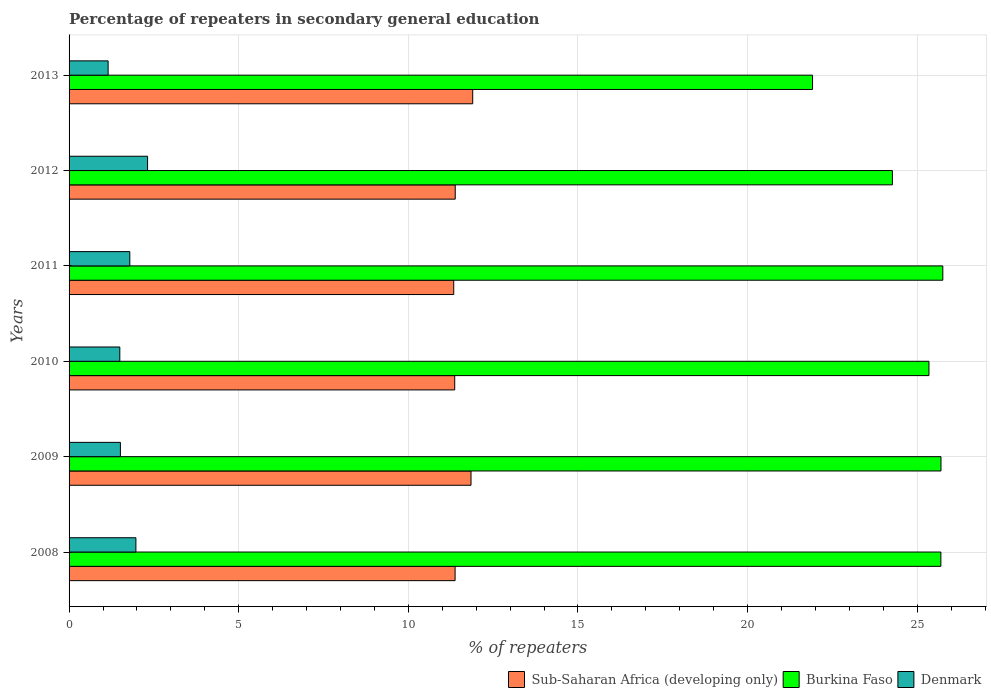How many different coloured bars are there?
Keep it short and to the point. 3. How many groups of bars are there?
Keep it short and to the point. 6. How many bars are there on the 6th tick from the top?
Offer a terse response. 3. How many bars are there on the 4th tick from the bottom?
Your response must be concise. 3. What is the percentage of repeaters in secondary general education in Sub-Saharan Africa (developing only) in 2012?
Offer a very short reply. 11.38. Across all years, what is the maximum percentage of repeaters in secondary general education in Sub-Saharan Africa (developing only)?
Your answer should be very brief. 11.9. Across all years, what is the minimum percentage of repeaters in secondary general education in Burkina Faso?
Keep it short and to the point. 21.91. In which year was the percentage of repeaters in secondary general education in Sub-Saharan Africa (developing only) maximum?
Make the answer very short. 2013. In which year was the percentage of repeaters in secondary general education in Denmark minimum?
Provide a succinct answer. 2013. What is the total percentage of repeaters in secondary general education in Sub-Saharan Africa (developing only) in the graph?
Provide a short and direct response. 69.21. What is the difference between the percentage of repeaters in secondary general education in Denmark in 2009 and that in 2010?
Provide a short and direct response. 0.02. What is the difference between the percentage of repeaters in secondary general education in Denmark in 2010 and the percentage of repeaters in secondary general education in Burkina Faso in 2013?
Your response must be concise. -20.42. What is the average percentage of repeaters in secondary general education in Sub-Saharan Africa (developing only) per year?
Make the answer very short. 11.54. In the year 2009, what is the difference between the percentage of repeaters in secondary general education in Burkina Faso and percentage of repeaters in secondary general education in Denmark?
Keep it short and to the point. 24.19. What is the ratio of the percentage of repeaters in secondary general education in Sub-Saharan Africa (developing only) in 2010 to that in 2013?
Offer a terse response. 0.96. Is the percentage of repeaters in secondary general education in Burkina Faso in 2012 less than that in 2013?
Make the answer very short. No. Is the difference between the percentage of repeaters in secondary general education in Burkina Faso in 2010 and 2013 greater than the difference between the percentage of repeaters in secondary general education in Denmark in 2010 and 2013?
Provide a succinct answer. Yes. What is the difference between the highest and the second highest percentage of repeaters in secondary general education in Burkina Faso?
Ensure brevity in your answer.  0.05. What is the difference between the highest and the lowest percentage of repeaters in secondary general education in Burkina Faso?
Make the answer very short. 3.84. Is the sum of the percentage of repeaters in secondary general education in Sub-Saharan Africa (developing only) in 2011 and 2012 greater than the maximum percentage of repeaters in secondary general education in Denmark across all years?
Your answer should be very brief. Yes. What does the 2nd bar from the top in 2012 represents?
Give a very brief answer. Burkina Faso. What does the 2nd bar from the bottom in 2009 represents?
Ensure brevity in your answer.  Burkina Faso. Is it the case that in every year, the sum of the percentage of repeaters in secondary general education in Denmark and percentage of repeaters in secondary general education in Burkina Faso is greater than the percentage of repeaters in secondary general education in Sub-Saharan Africa (developing only)?
Your answer should be compact. Yes. How many bars are there?
Your response must be concise. 18. Are all the bars in the graph horizontal?
Provide a succinct answer. Yes. Are the values on the major ticks of X-axis written in scientific E-notation?
Your answer should be compact. No. How many legend labels are there?
Make the answer very short. 3. What is the title of the graph?
Give a very brief answer. Percentage of repeaters in secondary general education. What is the label or title of the X-axis?
Make the answer very short. % of repeaters. What is the label or title of the Y-axis?
Ensure brevity in your answer.  Years. What is the % of repeaters in Sub-Saharan Africa (developing only) in 2008?
Offer a very short reply. 11.38. What is the % of repeaters of Burkina Faso in 2008?
Your response must be concise. 25.7. What is the % of repeaters of Denmark in 2008?
Provide a succinct answer. 1.97. What is the % of repeaters of Sub-Saharan Africa (developing only) in 2009?
Your response must be concise. 11.85. What is the % of repeaters of Burkina Faso in 2009?
Make the answer very short. 25.7. What is the % of repeaters in Denmark in 2009?
Give a very brief answer. 1.51. What is the % of repeaters in Sub-Saharan Africa (developing only) in 2010?
Offer a very short reply. 11.37. What is the % of repeaters in Burkina Faso in 2010?
Make the answer very short. 25.35. What is the % of repeaters in Denmark in 2010?
Your answer should be very brief. 1.5. What is the % of repeaters of Sub-Saharan Africa (developing only) in 2011?
Make the answer very short. 11.34. What is the % of repeaters of Burkina Faso in 2011?
Your answer should be compact. 25.75. What is the % of repeaters in Denmark in 2011?
Offer a very short reply. 1.79. What is the % of repeaters in Sub-Saharan Africa (developing only) in 2012?
Provide a succinct answer. 11.38. What is the % of repeaters in Burkina Faso in 2012?
Your answer should be compact. 24.27. What is the % of repeaters in Denmark in 2012?
Your answer should be very brief. 2.31. What is the % of repeaters of Sub-Saharan Africa (developing only) in 2013?
Offer a terse response. 11.9. What is the % of repeaters in Burkina Faso in 2013?
Make the answer very short. 21.91. What is the % of repeaters in Denmark in 2013?
Offer a very short reply. 1.15. Across all years, what is the maximum % of repeaters in Sub-Saharan Africa (developing only)?
Your answer should be compact. 11.9. Across all years, what is the maximum % of repeaters in Burkina Faso?
Offer a terse response. 25.75. Across all years, what is the maximum % of repeaters of Denmark?
Offer a terse response. 2.31. Across all years, what is the minimum % of repeaters in Sub-Saharan Africa (developing only)?
Make the answer very short. 11.34. Across all years, what is the minimum % of repeaters of Burkina Faso?
Your response must be concise. 21.91. Across all years, what is the minimum % of repeaters of Denmark?
Ensure brevity in your answer.  1.15. What is the total % of repeaters in Sub-Saharan Africa (developing only) in the graph?
Give a very brief answer. 69.21. What is the total % of repeaters in Burkina Faso in the graph?
Your response must be concise. 148.68. What is the total % of repeaters in Denmark in the graph?
Provide a short and direct response. 10.23. What is the difference between the % of repeaters in Sub-Saharan Africa (developing only) in 2008 and that in 2009?
Keep it short and to the point. -0.47. What is the difference between the % of repeaters of Burkina Faso in 2008 and that in 2009?
Ensure brevity in your answer.  -0. What is the difference between the % of repeaters of Denmark in 2008 and that in 2009?
Your response must be concise. 0.46. What is the difference between the % of repeaters in Sub-Saharan Africa (developing only) in 2008 and that in 2010?
Offer a terse response. 0.01. What is the difference between the % of repeaters of Burkina Faso in 2008 and that in 2010?
Your answer should be very brief. 0.35. What is the difference between the % of repeaters in Denmark in 2008 and that in 2010?
Offer a terse response. 0.47. What is the difference between the % of repeaters of Sub-Saharan Africa (developing only) in 2008 and that in 2011?
Your answer should be compact. 0.04. What is the difference between the % of repeaters in Burkina Faso in 2008 and that in 2011?
Ensure brevity in your answer.  -0.06. What is the difference between the % of repeaters of Denmark in 2008 and that in 2011?
Keep it short and to the point. 0.18. What is the difference between the % of repeaters of Sub-Saharan Africa (developing only) in 2008 and that in 2012?
Give a very brief answer. -0. What is the difference between the % of repeaters in Burkina Faso in 2008 and that in 2012?
Ensure brevity in your answer.  1.43. What is the difference between the % of repeaters in Denmark in 2008 and that in 2012?
Your response must be concise. -0.34. What is the difference between the % of repeaters of Sub-Saharan Africa (developing only) in 2008 and that in 2013?
Your response must be concise. -0.52. What is the difference between the % of repeaters in Burkina Faso in 2008 and that in 2013?
Your response must be concise. 3.78. What is the difference between the % of repeaters in Denmark in 2008 and that in 2013?
Offer a terse response. 0.82. What is the difference between the % of repeaters in Sub-Saharan Africa (developing only) in 2009 and that in 2010?
Your response must be concise. 0.48. What is the difference between the % of repeaters of Burkina Faso in 2009 and that in 2010?
Make the answer very short. 0.35. What is the difference between the % of repeaters in Denmark in 2009 and that in 2010?
Give a very brief answer. 0.02. What is the difference between the % of repeaters of Sub-Saharan Africa (developing only) in 2009 and that in 2011?
Provide a succinct answer. 0.51. What is the difference between the % of repeaters in Burkina Faso in 2009 and that in 2011?
Your response must be concise. -0.05. What is the difference between the % of repeaters in Denmark in 2009 and that in 2011?
Offer a very short reply. -0.28. What is the difference between the % of repeaters of Sub-Saharan Africa (developing only) in 2009 and that in 2012?
Provide a succinct answer. 0.47. What is the difference between the % of repeaters in Burkina Faso in 2009 and that in 2012?
Give a very brief answer. 1.43. What is the difference between the % of repeaters in Denmark in 2009 and that in 2012?
Offer a terse response. -0.8. What is the difference between the % of repeaters in Sub-Saharan Africa (developing only) in 2009 and that in 2013?
Provide a short and direct response. -0.05. What is the difference between the % of repeaters in Burkina Faso in 2009 and that in 2013?
Keep it short and to the point. 3.79. What is the difference between the % of repeaters in Denmark in 2009 and that in 2013?
Offer a terse response. 0.36. What is the difference between the % of repeaters in Sub-Saharan Africa (developing only) in 2010 and that in 2011?
Provide a succinct answer. 0.03. What is the difference between the % of repeaters of Burkina Faso in 2010 and that in 2011?
Ensure brevity in your answer.  -0.41. What is the difference between the % of repeaters of Denmark in 2010 and that in 2011?
Your answer should be very brief. -0.29. What is the difference between the % of repeaters in Sub-Saharan Africa (developing only) in 2010 and that in 2012?
Provide a succinct answer. -0.01. What is the difference between the % of repeaters of Burkina Faso in 2010 and that in 2012?
Ensure brevity in your answer.  1.08. What is the difference between the % of repeaters in Denmark in 2010 and that in 2012?
Make the answer very short. -0.82. What is the difference between the % of repeaters in Sub-Saharan Africa (developing only) in 2010 and that in 2013?
Your answer should be compact. -0.53. What is the difference between the % of repeaters of Burkina Faso in 2010 and that in 2013?
Your response must be concise. 3.43. What is the difference between the % of repeaters of Denmark in 2010 and that in 2013?
Ensure brevity in your answer.  0.34. What is the difference between the % of repeaters of Sub-Saharan Africa (developing only) in 2011 and that in 2012?
Give a very brief answer. -0.04. What is the difference between the % of repeaters of Burkina Faso in 2011 and that in 2012?
Offer a very short reply. 1.49. What is the difference between the % of repeaters of Denmark in 2011 and that in 2012?
Your answer should be compact. -0.52. What is the difference between the % of repeaters in Sub-Saharan Africa (developing only) in 2011 and that in 2013?
Provide a short and direct response. -0.56. What is the difference between the % of repeaters of Burkina Faso in 2011 and that in 2013?
Provide a succinct answer. 3.84. What is the difference between the % of repeaters of Denmark in 2011 and that in 2013?
Give a very brief answer. 0.64. What is the difference between the % of repeaters in Sub-Saharan Africa (developing only) in 2012 and that in 2013?
Keep it short and to the point. -0.52. What is the difference between the % of repeaters of Burkina Faso in 2012 and that in 2013?
Your response must be concise. 2.35. What is the difference between the % of repeaters of Denmark in 2012 and that in 2013?
Your answer should be compact. 1.16. What is the difference between the % of repeaters of Sub-Saharan Africa (developing only) in 2008 and the % of repeaters of Burkina Faso in 2009?
Provide a succinct answer. -14.32. What is the difference between the % of repeaters of Sub-Saharan Africa (developing only) in 2008 and the % of repeaters of Denmark in 2009?
Provide a succinct answer. 9.87. What is the difference between the % of repeaters of Burkina Faso in 2008 and the % of repeaters of Denmark in 2009?
Offer a very short reply. 24.18. What is the difference between the % of repeaters of Sub-Saharan Africa (developing only) in 2008 and the % of repeaters of Burkina Faso in 2010?
Your answer should be very brief. -13.97. What is the difference between the % of repeaters of Sub-Saharan Africa (developing only) in 2008 and the % of repeaters of Denmark in 2010?
Your answer should be compact. 9.88. What is the difference between the % of repeaters in Burkina Faso in 2008 and the % of repeaters in Denmark in 2010?
Provide a short and direct response. 24.2. What is the difference between the % of repeaters of Sub-Saharan Africa (developing only) in 2008 and the % of repeaters of Burkina Faso in 2011?
Provide a short and direct response. -14.38. What is the difference between the % of repeaters of Sub-Saharan Africa (developing only) in 2008 and the % of repeaters of Denmark in 2011?
Keep it short and to the point. 9.59. What is the difference between the % of repeaters of Burkina Faso in 2008 and the % of repeaters of Denmark in 2011?
Provide a succinct answer. 23.91. What is the difference between the % of repeaters of Sub-Saharan Africa (developing only) in 2008 and the % of repeaters of Burkina Faso in 2012?
Offer a terse response. -12.89. What is the difference between the % of repeaters of Sub-Saharan Africa (developing only) in 2008 and the % of repeaters of Denmark in 2012?
Keep it short and to the point. 9.06. What is the difference between the % of repeaters of Burkina Faso in 2008 and the % of repeaters of Denmark in 2012?
Provide a short and direct response. 23.38. What is the difference between the % of repeaters in Sub-Saharan Africa (developing only) in 2008 and the % of repeaters in Burkina Faso in 2013?
Offer a very short reply. -10.54. What is the difference between the % of repeaters of Sub-Saharan Africa (developing only) in 2008 and the % of repeaters of Denmark in 2013?
Ensure brevity in your answer.  10.23. What is the difference between the % of repeaters of Burkina Faso in 2008 and the % of repeaters of Denmark in 2013?
Your answer should be compact. 24.55. What is the difference between the % of repeaters in Sub-Saharan Africa (developing only) in 2009 and the % of repeaters in Burkina Faso in 2010?
Your answer should be very brief. -13.5. What is the difference between the % of repeaters of Sub-Saharan Africa (developing only) in 2009 and the % of repeaters of Denmark in 2010?
Provide a short and direct response. 10.35. What is the difference between the % of repeaters in Burkina Faso in 2009 and the % of repeaters in Denmark in 2010?
Make the answer very short. 24.2. What is the difference between the % of repeaters of Sub-Saharan Africa (developing only) in 2009 and the % of repeaters of Burkina Faso in 2011?
Offer a terse response. -13.91. What is the difference between the % of repeaters of Sub-Saharan Africa (developing only) in 2009 and the % of repeaters of Denmark in 2011?
Your answer should be very brief. 10.06. What is the difference between the % of repeaters of Burkina Faso in 2009 and the % of repeaters of Denmark in 2011?
Make the answer very short. 23.91. What is the difference between the % of repeaters in Sub-Saharan Africa (developing only) in 2009 and the % of repeaters in Burkina Faso in 2012?
Your answer should be compact. -12.42. What is the difference between the % of repeaters of Sub-Saharan Africa (developing only) in 2009 and the % of repeaters of Denmark in 2012?
Your answer should be compact. 9.53. What is the difference between the % of repeaters of Burkina Faso in 2009 and the % of repeaters of Denmark in 2012?
Provide a short and direct response. 23.39. What is the difference between the % of repeaters in Sub-Saharan Africa (developing only) in 2009 and the % of repeaters in Burkina Faso in 2013?
Provide a short and direct response. -10.07. What is the difference between the % of repeaters in Sub-Saharan Africa (developing only) in 2009 and the % of repeaters in Denmark in 2013?
Keep it short and to the point. 10.7. What is the difference between the % of repeaters of Burkina Faso in 2009 and the % of repeaters of Denmark in 2013?
Offer a very short reply. 24.55. What is the difference between the % of repeaters of Sub-Saharan Africa (developing only) in 2010 and the % of repeaters of Burkina Faso in 2011?
Make the answer very short. -14.39. What is the difference between the % of repeaters of Sub-Saharan Africa (developing only) in 2010 and the % of repeaters of Denmark in 2011?
Give a very brief answer. 9.58. What is the difference between the % of repeaters of Burkina Faso in 2010 and the % of repeaters of Denmark in 2011?
Your response must be concise. 23.56. What is the difference between the % of repeaters of Sub-Saharan Africa (developing only) in 2010 and the % of repeaters of Burkina Faso in 2012?
Offer a terse response. -12.9. What is the difference between the % of repeaters in Sub-Saharan Africa (developing only) in 2010 and the % of repeaters in Denmark in 2012?
Keep it short and to the point. 9.05. What is the difference between the % of repeaters in Burkina Faso in 2010 and the % of repeaters in Denmark in 2012?
Offer a terse response. 23.03. What is the difference between the % of repeaters of Sub-Saharan Africa (developing only) in 2010 and the % of repeaters of Burkina Faso in 2013?
Give a very brief answer. -10.55. What is the difference between the % of repeaters in Sub-Saharan Africa (developing only) in 2010 and the % of repeaters in Denmark in 2013?
Make the answer very short. 10.22. What is the difference between the % of repeaters of Burkina Faso in 2010 and the % of repeaters of Denmark in 2013?
Offer a very short reply. 24.19. What is the difference between the % of repeaters of Sub-Saharan Africa (developing only) in 2011 and the % of repeaters of Burkina Faso in 2012?
Your answer should be very brief. -12.93. What is the difference between the % of repeaters in Sub-Saharan Africa (developing only) in 2011 and the % of repeaters in Denmark in 2012?
Give a very brief answer. 9.02. What is the difference between the % of repeaters in Burkina Faso in 2011 and the % of repeaters in Denmark in 2012?
Your answer should be compact. 23.44. What is the difference between the % of repeaters of Sub-Saharan Africa (developing only) in 2011 and the % of repeaters of Burkina Faso in 2013?
Make the answer very short. -10.58. What is the difference between the % of repeaters of Sub-Saharan Africa (developing only) in 2011 and the % of repeaters of Denmark in 2013?
Your answer should be compact. 10.19. What is the difference between the % of repeaters of Burkina Faso in 2011 and the % of repeaters of Denmark in 2013?
Your answer should be compact. 24.6. What is the difference between the % of repeaters of Sub-Saharan Africa (developing only) in 2012 and the % of repeaters of Burkina Faso in 2013?
Ensure brevity in your answer.  -10.53. What is the difference between the % of repeaters in Sub-Saharan Africa (developing only) in 2012 and the % of repeaters in Denmark in 2013?
Your response must be concise. 10.23. What is the difference between the % of repeaters in Burkina Faso in 2012 and the % of repeaters in Denmark in 2013?
Your response must be concise. 23.12. What is the average % of repeaters of Sub-Saharan Africa (developing only) per year?
Make the answer very short. 11.54. What is the average % of repeaters of Burkina Faso per year?
Provide a succinct answer. 24.78. What is the average % of repeaters of Denmark per year?
Make the answer very short. 1.71. In the year 2008, what is the difference between the % of repeaters of Sub-Saharan Africa (developing only) and % of repeaters of Burkina Faso?
Offer a very short reply. -14.32. In the year 2008, what is the difference between the % of repeaters of Sub-Saharan Africa (developing only) and % of repeaters of Denmark?
Keep it short and to the point. 9.41. In the year 2008, what is the difference between the % of repeaters in Burkina Faso and % of repeaters in Denmark?
Your response must be concise. 23.73. In the year 2009, what is the difference between the % of repeaters of Sub-Saharan Africa (developing only) and % of repeaters of Burkina Faso?
Keep it short and to the point. -13.85. In the year 2009, what is the difference between the % of repeaters in Sub-Saharan Africa (developing only) and % of repeaters in Denmark?
Ensure brevity in your answer.  10.33. In the year 2009, what is the difference between the % of repeaters in Burkina Faso and % of repeaters in Denmark?
Your answer should be very brief. 24.19. In the year 2010, what is the difference between the % of repeaters of Sub-Saharan Africa (developing only) and % of repeaters of Burkina Faso?
Provide a succinct answer. -13.98. In the year 2010, what is the difference between the % of repeaters in Sub-Saharan Africa (developing only) and % of repeaters in Denmark?
Your response must be concise. 9.87. In the year 2010, what is the difference between the % of repeaters in Burkina Faso and % of repeaters in Denmark?
Your answer should be very brief. 23.85. In the year 2011, what is the difference between the % of repeaters of Sub-Saharan Africa (developing only) and % of repeaters of Burkina Faso?
Provide a short and direct response. -14.42. In the year 2011, what is the difference between the % of repeaters of Sub-Saharan Africa (developing only) and % of repeaters of Denmark?
Your answer should be very brief. 9.55. In the year 2011, what is the difference between the % of repeaters in Burkina Faso and % of repeaters in Denmark?
Ensure brevity in your answer.  23.96. In the year 2012, what is the difference between the % of repeaters of Sub-Saharan Africa (developing only) and % of repeaters of Burkina Faso?
Offer a very short reply. -12.89. In the year 2012, what is the difference between the % of repeaters in Sub-Saharan Africa (developing only) and % of repeaters in Denmark?
Your answer should be very brief. 9.07. In the year 2012, what is the difference between the % of repeaters in Burkina Faso and % of repeaters in Denmark?
Provide a short and direct response. 21.95. In the year 2013, what is the difference between the % of repeaters in Sub-Saharan Africa (developing only) and % of repeaters in Burkina Faso?
Your answer should be very brief. -10.02. In the year 2013, what is the difference between the % of repeaters of Sub-Saharan Africa (developing only) and % of repeaters of Denmark?
Your answer should be very brief. 10.75. In the year 2013, what is the difference between the % of repeaters of Burkina Faso and % of repeaters of Denmark?
Your answer should be very brief. 20.76. What is the ratio of the % of repeaters in Sub-Saharan Africa (developing only) in 2008 to that in 2009?
Make the answer very short. 0.96. What is the ratio of the % of repeaters in Burkina Faso in 2008 to that in 2009?
Give a very brief answer. 1. What is the ratio of the % of repeaters of Denmark in 2008 to that in 2009?
Provide a succinct answer. 1.3. What is the ratio of the % of repeaters of Burkina Faso in 2008 to that in 2010?
Ensure brevity in your answer.  1.01. What is the ratio of the % of repeaters in Denmark in 2008 to that in 2010?
Your answer should be compact. 1.32. What is the ratio of the % of repeaters in Denmark in 2008 to that in 2011?
Offer a very short reply. 1.1. What is the ratio of the % of repeaters in Sub-Saharan Africa (developing only) in 2008 to that in 2012?
Your answer should be compact. 1. What is the ratio of the % of repeaters of Burkina Faso in 2008 to that in 2012?
Give a very brief answer. 1.06. What is the ratio of the % of repeaters in Denmark in 2008 to that in 2012?
Offer a very short reply. 0.85. What is the ratio of the % of repeaters of Sub-Saharan Africa (developing only) in 2008 to that in 2013?
Your response must be concise. 0.96. What is the ratio of the % of repeaters in Burkina Faso in 2008 to that in 2013?
Keep it short and to the point. 1.17. What is the ratio of the % of repeaters of Denmark in 2008 to that in 2013?
Offer a very short reply. 1.71. What is the ratio of the % of repeaters of Sub-Saharan Africa (developing only) in 2009 to that in 2010?
Keep it short and to the point. 1.04. What is the ratio of the % of repeaters in Burkina Faso in 2009 to that in 2010?
Ensure brevity in your answer.  1.01. What is the ratio of the % of repeaters in Denmark in 2009 to that in 2010?
Give a very brief answer. 1.01. What is the ratio of the % of repeaters in Sub-Saharan Africa (developing only) in 2009 to that in 2011?
Your answer should be very brief. 1.04. What is the ratio of the % of repeaters of Denmark in 2009 to that in 2011?
Provide a succinct answer. 0.85. What is the ratio of the % of repeaters in Sub-Saharan Africa (developing only) in 2009 to that in 2012?
Offer a very short reply. 1.04. What is the ratio of the % of repeaters of Burkina Faso in 2009 to that in 2012?
Your response must be concise. 1.06. What is the ratio of the % of repeaters of Denmark in 2009 to that in 2012?
Make the answer very short. 0.65. What is the ratio of the % of repeaters of Sub-Saharan Africa (developing only) in 2009 to that in 2013?
Provide a succinct answer. 1. What is the ratio of the % of repeaters of Burkina Faso in 2009 to that in 2013?
Keep it short and to the point. 1.17. What is the ratio of the % of repeaters of Denmark in 2009 to that in 2013?
Your answer should be compact. 1.31. What is the ratio of the % of repeaters in Sub-Saharan Africa (developing only) in 2010 to that in 2011?
Offer a terse response. 1. What is the ratio of the % of repeaters in Burkina Faso in 2010 to that in 2011?
Keep it short and to the point. 0.98. What is the ratio of the % of repeaters in Denmark in 2010 to that in 2011?
Ensure brevity in your answer.  0.84. What is the ratio of the % of repeaters in Sub-Saharan Africa (developing only) in 2010 to that in 2012?
Provide a succinct answer. 1. What is the ratio of the % of repeaters of Burkina Faso in 2010 to that in 2012?
Give a very brief answer. 1.04. What is the ratio of the % of repeaters in Denmark in 2010 to that in 2012?
Ensure brevity in your answer.  0.65. What is the ratio of the % of repeaters in Sub-Saharan Africa (developing only) in 2010 to that in 2013?
Keep it short and to the point. 0.96. What is the ratio of the % of repeaters in Burkina Faso in 2010 to that in 2013?
Offer a very short reply. 1.16. What is the ratio of the % of repeaters in Denmark in 2010 to that in 2013?
Give a very brief answer. 1.3. What is the ratio of the % of repeaters of Burkina Faso in 2011 to that in 2012?
Provide a short and direct response. 1.06. What is the ratio of the % of repeaters of Denmark in 2011 to that in 2012?
Provide a short and direct response. 0.77. What is the ratio of the % of repeaters in Sub-Saharan Africa (developing only) in 2011 to that in 2013?
Give a very brief answer. 0.95. What is the ratio of the % of repeaters in Burkina Faso in 2011 to that in 2013?
Offer a terse response. 1.18. What is the ratio of the % of repeaters in Denmark in 2011 to that in 2013?
Provide a short and direct response. 1.56. What is the ratio of the % of repeaters of Sub-Saharan Africa (developing only) in 2012 to that in 2013?
Offer a very short reply. 0.96. What is the ratio of the % of repeaters of Burkina Faso in 2012 to that in 2013?
Give a very brief answer. 1.11. What is the ratio of the % of repeaters in Denmark in 2012 to that in 2013?
Offer a very short reply. 2.01. What is the difference between the highest and the second highest % of repeaters of Sub-Saharan Africa (developing only)?
Keep it short and to the point. 0.05. What is the difference between the highest and the second highest % of repeaters of Burkina Faso?
Your response must be concise. 0.05. What is the difference between the highest and the second highest % of repeaters of Denmark?
Your answer should be compact. 0.34. What is the difference between the highest and the lowest % of repeaters in Sub-Saharan Africa (developing only)?
Provide a short and direct response. 0.56. What is the difference between the highest and the lowest % of repeaters in Burkina Faso?
Give a very brief answer. 3.84. What is the difference between the highest and the lowest % of repeaters of Denmark?
Your answer should be compact. 1.16. 